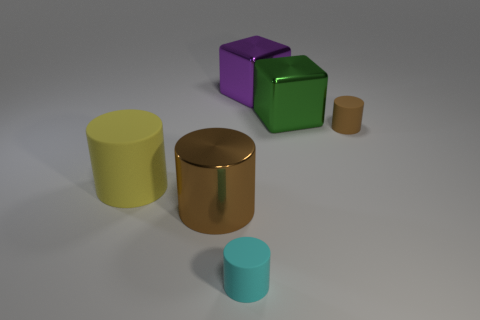Can you describe the colors and shapes of the objects in the picture? Certainly! There are five objects with a mix of shapes and colors. Starting from the left, there is a yellow cylindrical object, followed by a large copper-toned cylinder, then a central purple cube, a green cube that's slightly smaller, and finally, a small brown cylinder. The cylinders are smooth with rounded edges, while the cubes have sharp, defined edges. 